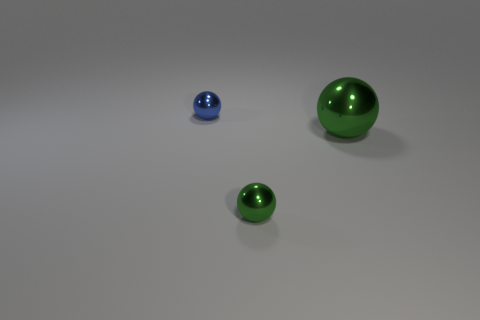There is a small green metallic object; what number of big balls are to the left of it?
Your response must be concise. 0. How big is the metal sphere that is to the right of the green metal thing in front of the large object?
Your response must be concise. Large. There is a green object that is right of the tiny green metallic sphere; is its shape the same as the green object on the left side of the big thing?
Provide a short and direct response. Yes. The tiny object that is on the left side of the tiny metallic thing on the right side of the blue metallic object is what shape?
Your response must be concise. Sphere. There is a sphere that is both to the left of the large sphere and behind the tiny green metal ball; what is its size?
Your answer should be compact. Small. There is a tiny green thing; is it the same shape as the metallic object that is behind the large green sphere?
Give a very brief answer. Yes. The other green shiny thing that is the same shape as the big green metal object is what size?
Give a very brief answer. Small. There is a big sphere; does it have the same color as the sphere that is behind the big metal thing?
Your response must be concise. No. How many other things are there of the same size as the blue thing?
Ensure brevity in your answer.  1. There is a large metallic thing on the right side of the small thing that is behind the tiny shiny thing on the right side of the tiny blue thing; what is its shape?
Offer a very short reply. Sphere. 